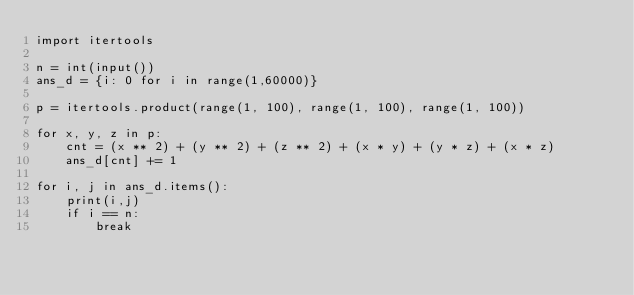<code> <loc_0><loc_0><loc_500><loc_500><_Python_>import itertools

n = int(input())
ans_d = {i: 0 for i in range(1,60000)}

p = itertools.product(range(1, 100), range(1, 100), range(1, 100))

for x, y, z in p:
    cnt = (x ** 2) + (y ** 2) + (z ** 2) + (x * y) + (y * z) + (x * z)
    ans_d[cnt] += 1

for i, j in ans_d.items():
    print(i,j)
    if i == n:
        break</code> 